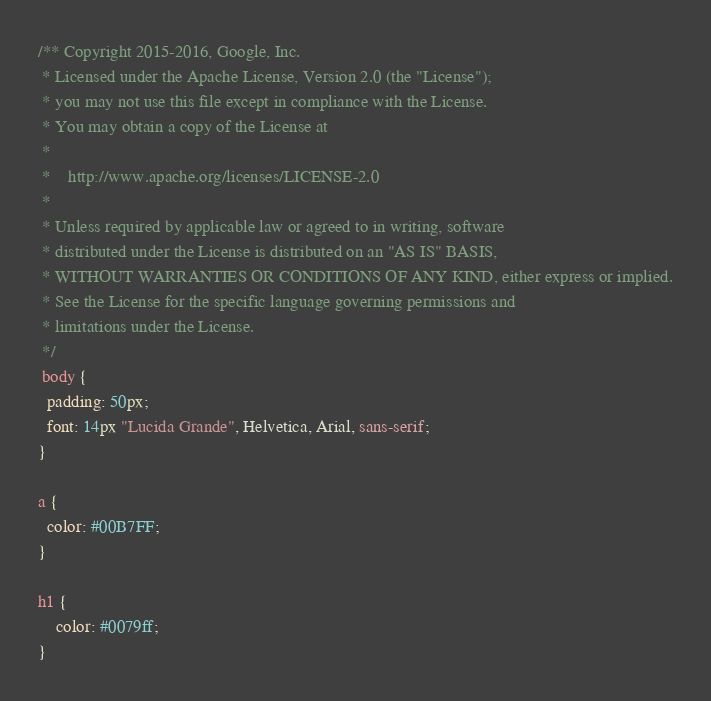Convert code to text. <code><loc_0><loc_0><loc_500><loc_500><_CSS_>/** Copyright 2015-2016, Google, Inc.
 * Licensed under the Apache License, Version 2.0 (the "License");
 * you may not use this file except in compliance with the License.
 * You may obtain a copy of the License at
 *
 *    http://www.apache.org/licenses/LICENSE-2.0
 *
 * Unless required by applicable law or agreed to in writing, software
 * distributed under the License is distributed on an "AS IS" BASIS,
 * WITHOUT WARRANTIES OR CONDITIONS OF ANY KIND, either express or implied.
 * See the License for the specific language governing permissions and
 * limitations under the License.
 */
 body {
  padding: 50px;
  font: 14px "Lucida Grande", Helvetica, Arial, sans-serif;
}

a {
  color: #00B7FF;
}

h1 {
	color: #0079ff;
}</code> 